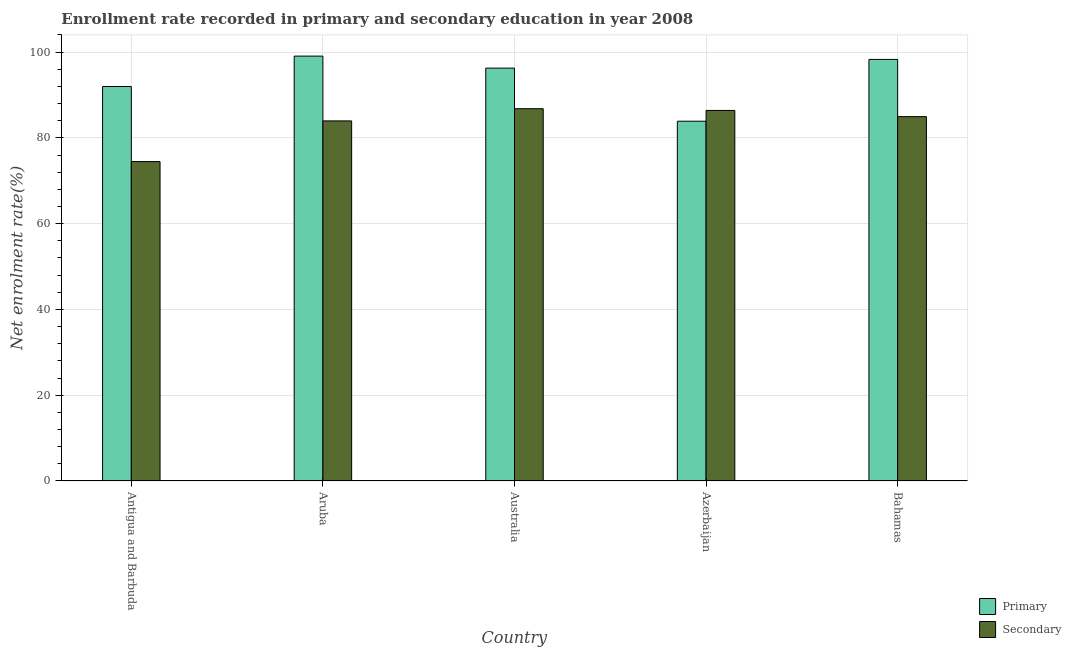How many different coloured bars are there?
Provide a short and direct response. 2. How many groups of bars are there?
Give a very brief answer. 5. Are the number of bars on each tick of the X-axis equal?
Your response must be concise. Yes. What is the label of the 4th group of bars from the left?
Offer a very short reply. Azerbaijan. In how many cases, is the number of bars for a given country not equal to the number of legend labels?
Make the answer very short. 0. What is the enrollment rate in secondary education in Azerbaijan?
Make the answer very short. 86.4. Across all countries, what is the maximum enrollment rate in primary education?
Provide a succinct answer. 99.07. Across all countries, what is the minimum enrollment rate in secondary education?
Ensure brevity in your answer.  74.48. In which country was the enrollment rate in primary education maximum?
Your answer should be very brief. Aruba. In which country was the enrollment rate in secondary education minimum?
Your answer should be compact. Antigua and Barbuda. What is the total enrollment rate in primary education in the graph?
Give a very brief answer. 469.51. What is the difference between the enrollment rate in secondary education in Azerbaijan and that in Bahamas?
Offer a terse response. 1.44. What is the difference between the enrollment rate in secondary education in Australia and the enrollment rate in primary education in Aruba?
Provide a succinct answer. -12.26. What is the average enrollment rate in secondary education per country?
Your response must be concise. 83.32. What is the difference between the enrollment rate in primary education and enrollment rate in secondary education in Aruba?
Your answer should be very brief. 15.11. What is the ratio of the enrollment rate in secondary education in Australia to that in Azerbaijan?
Provide a short and direct response. 1. What is the difference between the highest and the second highest enrollment rate in primary education?
Make the answer very short. 0.77. What is the difference between the highest and the lowest enrollment rate in primary education?
Your response must be concise. 15.18. Is the sum of the enrollment rate in primary education in Antigua and Barbuda and Aruba greater than the maximum enrollment rate in secondary education across all countries?
Offer a very short reply. Yes. What does the 2nd bar from the left in Australia represents?
Make the answer very short. Secondary. What does the 1st bar from the right in Bahamas represents?
Offer a terse response. Secondary. How many bars are there?
Keep it short and to the point. 10. Are all the bars in the graph horizontal?
Provide a succinct answer. No. How many countries are there in the graph?
Give a very brief answer. 5. What is the difference between two consecutive major ticks on the Y-axis?
Your answer should be compact. 20. Are the values on the major ticks of Y-axis written in scientific E-notation?
Provide a short and direct response. No. Does the graph contain any zero values?
Provide a succinct answer. No. Does the graph contain grids?
Give a very brief answer. Yes. How many legend labels are there?
Keep it short and to the point. 2. What is the title of the graph?
Your answer should be very brief. Enrollment rate recorded in primary and secondary education in year 2008. Does "Urban agglomerations" appear as one of the legend labels in the graph?
Ensure brevity in your answer.  No. What is the label or title of the X-axis?
Your answer should be compact. Country. What is the label or title of the Y-axis?
Keep it short and to the point. Net enrolment rate(%). What is the Net enrolment rate(%) of Primary in Antigua and Barbuda?
Make the answer very short. 91.98. What is the Net enrolment rate(%) in Secondary in Antigua and Barbuda?
Make the answer very short. 74.48. What is the Net enrolment rate(%) of Primary in Aruba?
Offer a terse response. 99.07. What is the Net enrolment rate(%) in Secondary in Aruba?
Your response must be concise. 83.96. What is the Net enrolment rate(%) in Primary in Australia?
Offer a terse response. 96.27. What is the Net enrolment rate(%) of Secondary in Australia?
Provide a succinct answer. 86.81. What is the Net enrolment rate(%) in Primary in Azerbaijan?
Give a very brief answer. 83.89. What is the Net enrolment rate(%) of Secondary in Azerbaijan?
Make the answer very short. 86.4. What is the Net enrolment rate(%) in Primary in Bahamas?
Offer a very short reply. 98.3. What is the Net enrolment rate(%) of Secondary in Bahamas?
Keep it short and to the point. 84.96. Across all countries, what is the maximum Net enrolment rate(%) of Primary?
Ensure brevity in your answer.  99.07. Across all countries, what is the maximum Net enrolment rate(%) in Secondary?
Provide a short and direct response. 86.81. Across all countries, what is the minimum Net enrolment rate(%) of Primary?
Offer a very short reply. 83.89. Across all countries, what is the minimum Net enrolment rate(%) in Secondary?
Ensure brevity in your answer.  74.48. What is the total Net enrolment rate(%) in Primary in the graph?
Give a very brief answer. 469.51. What is the total Net enrolment rate(%) in Secondary in the graph?
Keep it short and to the point. 416.61. What is the difference between the Net enrolment rate(%) of Primary in Antigua and Barbuda and that in Aruba?
Offer a very short reply. -7.09. What is the difference between the Net enrolment rate(%) of Secondary in Antigua and Barbuda and that in Aruba?
Provide a short and direct response. -9.48. What is the difference between the Net enrolment rate(%) of Primary in Antigua and Barbuda and that in Australia?
Offer a terse response. -4.29. What is the difference between the Net enrolment rate(%) in Secondary in Antigua and Barbuda and that in Australia?
Give a very brief answer. -12.33. What is the difference between the Net enrolment rate(%) of Primary in Antigua and Barbuda and that in Azerbaijan?
Make the answer very short. 8.09. What is the difference between the Net enrolment rate(%) in Secondary in Antigua and Barbuda and that in Azerbaijan?
Give a very brief answer. -11.92. What is the difference between the Net enrolment rate(%) of Primary in Antigua and Barbuda and that in Bahamas?
Make the answer very short. -6.32. What is the difference between the Net enrolment rate(%) in Secondary in Antigua and Barbuda and that in Bahamas?
Ensure brevity in your answer.  -10.48. What is the difference between the Net enrolment rate(%) in Primary in Aruba and that in Australia?
Keep it short and to the point. 2.8. What is the difference between the Net enrolment rate(%) in Secondary in Aruba and that in Australia?
Offer a very short reply. -2.85. What is the difference between the Net enrolment rate(%) in Primary in Aruba and that in Azerbaijan?
Your answer should be compact. 15.18. What is the difference between the Net enrolment rate(%) of Secondary in Aruba and that in Azerbaijan?
Give a very brief answer. -2.44. What is the difference between the Net enrolment rate(%) in Primary in Aruba and that in Bahamas?
Your answer should be compact. 0.77. What is the difference between the Net enrolment rate(%) of Secondary in Aruba and that in Bahamas?
Your answer should be compact. -0.99. What is the difference between the Net enrolment rate(%) of Primary in Australia and that in Azerbaijan?
Your answer should be compact. 12.38. What is the difference between the Net enrolment rate(%) of Secondary in Australia and that in Azerbaijan?
Provide a short and direct response. 0.41. What is the difference between the Net enrolment rate(%) in Primary in Australia and that in Bahamas?
Give a very brief answer. -2.03. What is the difference between the Net enrolment rate(%) in Secondary in Australia and that in Bahamas?
Provide a short and direct response. 1.85. What is the difference between the Net enrolment rate(%) of Primary in Azerbaijan and that in Bahamas?
Your response must be concise. -14.41. What is the difference between the Net enrolment rate(%) in Secondary in Azerbaijan and that in Bahamas?
Make the answer very short. 1.44. What is the difference between the Net enrolment rate(%) of Primary in Antigua and Barbuda and the Net enrolment rate(%) of Secondary in Aruba?
Make the answer very short. 8.02. What is the difference between the Net enrolment rate(%) in Primary in Antigua and Barbuda and the Net enrolment rate(%) in Secondary in Australia?
Provide a succinct answer. 5.17. What is the difference between the Net enrolment rate(%) in Primary in Antigua and Barbuda and the Net enrolment rate(%) in Secondary in Azerbaijan?
Your answer should be compact. 5.58. What is the difference between the Net enrolment rate(%) of Primary in Antigua and Barbuda and the Net enrolment rate(%) of Secondary in Bahamas?
Your response must be concise. 7.02. What is the difference between the Net enrolment rate(%) of Primary in Aruba and the Net enrolment rate(%) of Secondary in Australia?
Give a very brief answer. 12.26. What is the difference between the Net enrolment rate(%) of Primary in Aruba and the Net enrolment rate(%) of Secondary in Azerbaijan?
Keep it short and to the point. 12.67. What is the difference between the Net enrolment rate(%) of Primary in Aruba and the Net enrolment rate(%) of Secondary in Bahamas?
Your answer should be very brief. 14.11. What is the difference between the Net enrolment rate(%) in Primary in Australia and the Net enrolment rate(%) in Secondary in Azerbaijan?
Provide a succinct answer. 9.87. What is the difference between the Net enrolment rate(%) in Primary in Australia and the Net enrolment rate(%) in Secondary in Bahamas?
Offer a very short reply. 11.31. What is the difference between the Net enrolment rate(%) of Primary in Azerbaijan and the Net enrolment rate(%) of Secondary in Bahamas?
Your answer should be compact. -1.07. What is the average Net enrolment rate(%) of Primary per country?
Offer a terse response. 93.9. What is the average Net enrolment rate(%) of Secondary per country?
Your answer should be very brief. 83.32. What is the difference between the Net enrolment rate(%) of Primary and Net enrolment rate(%) of Secondary in Antigua and Barbuda?
Your response must be concise. 17.5. What is the difference between the Net enrolment rate(%) of Primary and Net enrolment rate(%) of Secondary in Aruba?
Ensure brevity in your answer.  15.11. What is the difference between the Net enrolment rate(%) in Primary and Net enrolment rate(%) in Secondary in Australia?
Your answer should be very brief. 9.46. What is the difference between the Net enrolment rate(%) in Primary and Net enrolment rate(%) in Secondary in Azerbaijan?
Ensure brevity in your answer.  -2.51. What is the difference between the Net enrolment rate(%) in Primary and Net enrolment rate(%) in Secondary in Bahamas?
Your answer should be compact. 13.34. What is the ratio of the Net enrolment rate(%) of Primary in Antigua and Barbuda to that in Aruba?
Your answer should be very brief. 0.93. What is the ratio of the Net enrolment rate(%) of Secondary in Antigua and Barbuda to that in Aruba?
Offer a terse response. 0.89. What is the ratio of the Net enrolment rate(%) of Primary in Antigua and Barbuda to that in Australia?
Provide a short and direct response. 0.96. What is the ratio of the Net enrolment rate(%) of Secondary in Antigua and Barbuda to that in Australia?
Provide a short and direct response. 0.86. What is the ratio of the Net enrolment rate(%) in Primary in Antigua and Barbuda to that in Azerbaijan?
Ensure brevity in your answer.  1.1. What is the ratio of the Net enrolment rate(%) in Secondary in Antigua and Barbuda to that in Azerbaijan?
Ensure brevity in your answer.  0.86. What is the ratio of the Net enrolment rate(%) in Primary in Antigua and Barbuda to that in Bahamas?
Your response must be concise. 0.94. What is the ratio of the Net enrolment rate(%) of Secondary in Antigua and Barbuda to that in Bahamas?
Give a very brief answer. 0.88. What is the ratio of the Net enrolment rate(%) of Primary in Aruba to that in Australia?
Keep it short and to the point. 1.03. What is the ratio of the Net enrolment rate(%) in Secondary in Aruba to that in Australia?
Provide a short and direct response. 0.97. What is the ratio of the Net enrolment rate(%) of Primary in Aruba to that in Azerbaijan?
Provide a short and direct response. 1.18. What is the ratio of the Net enrolment rate(%) in Secondary in Aruba to that in Azerbaijan?
Your answer should be very brief. 0.97. What is the ratio of the Net enrolment rate(%) of Secondary in Aruba to that in Bahamas?
Offer a terse response. 0.99. What is the ratio of the Net enrolment rate(%) of Primary in Australia to that in Azerbaijan?
Your answer should be compact. 1.15. What is the ratio of the Net enrolment rate(%) in Primary in Australia to that in Bahamas?
Provide a short and direct response. 0.98. What is the ratio of the Net enrolment rate(%) of Secondary in Australia to that in Bahamas?
Your answer should be very brief. 1.02. What is the ratio of the Net enrolment rate(%) in Primary in Azerbaijan to that in Bahamas?
Keep it short and to the point. 0.85. What is the ratio of the Net enrolment rate(%) of Secondary in Azerbaijan to that in Bahamas?
Your answer should be compact. 1.02. What is the difference between the highest and the second highest Net enrolment rate(%) in Primary?
Your response must be concise. 0.77. What is the difference between the highest and the second highest Net enrolment rate(%) in Secondary?
Your response must be concise. 0.41. What is the difference between the highest and the lowest Net enrolment rate(%) in Primary?
Provide a short and direct response. 15.18. What is the difference between the highest and the lowest Net enrolment rate(%) of Secondary?
Keep it short and to the point. 12.33. 